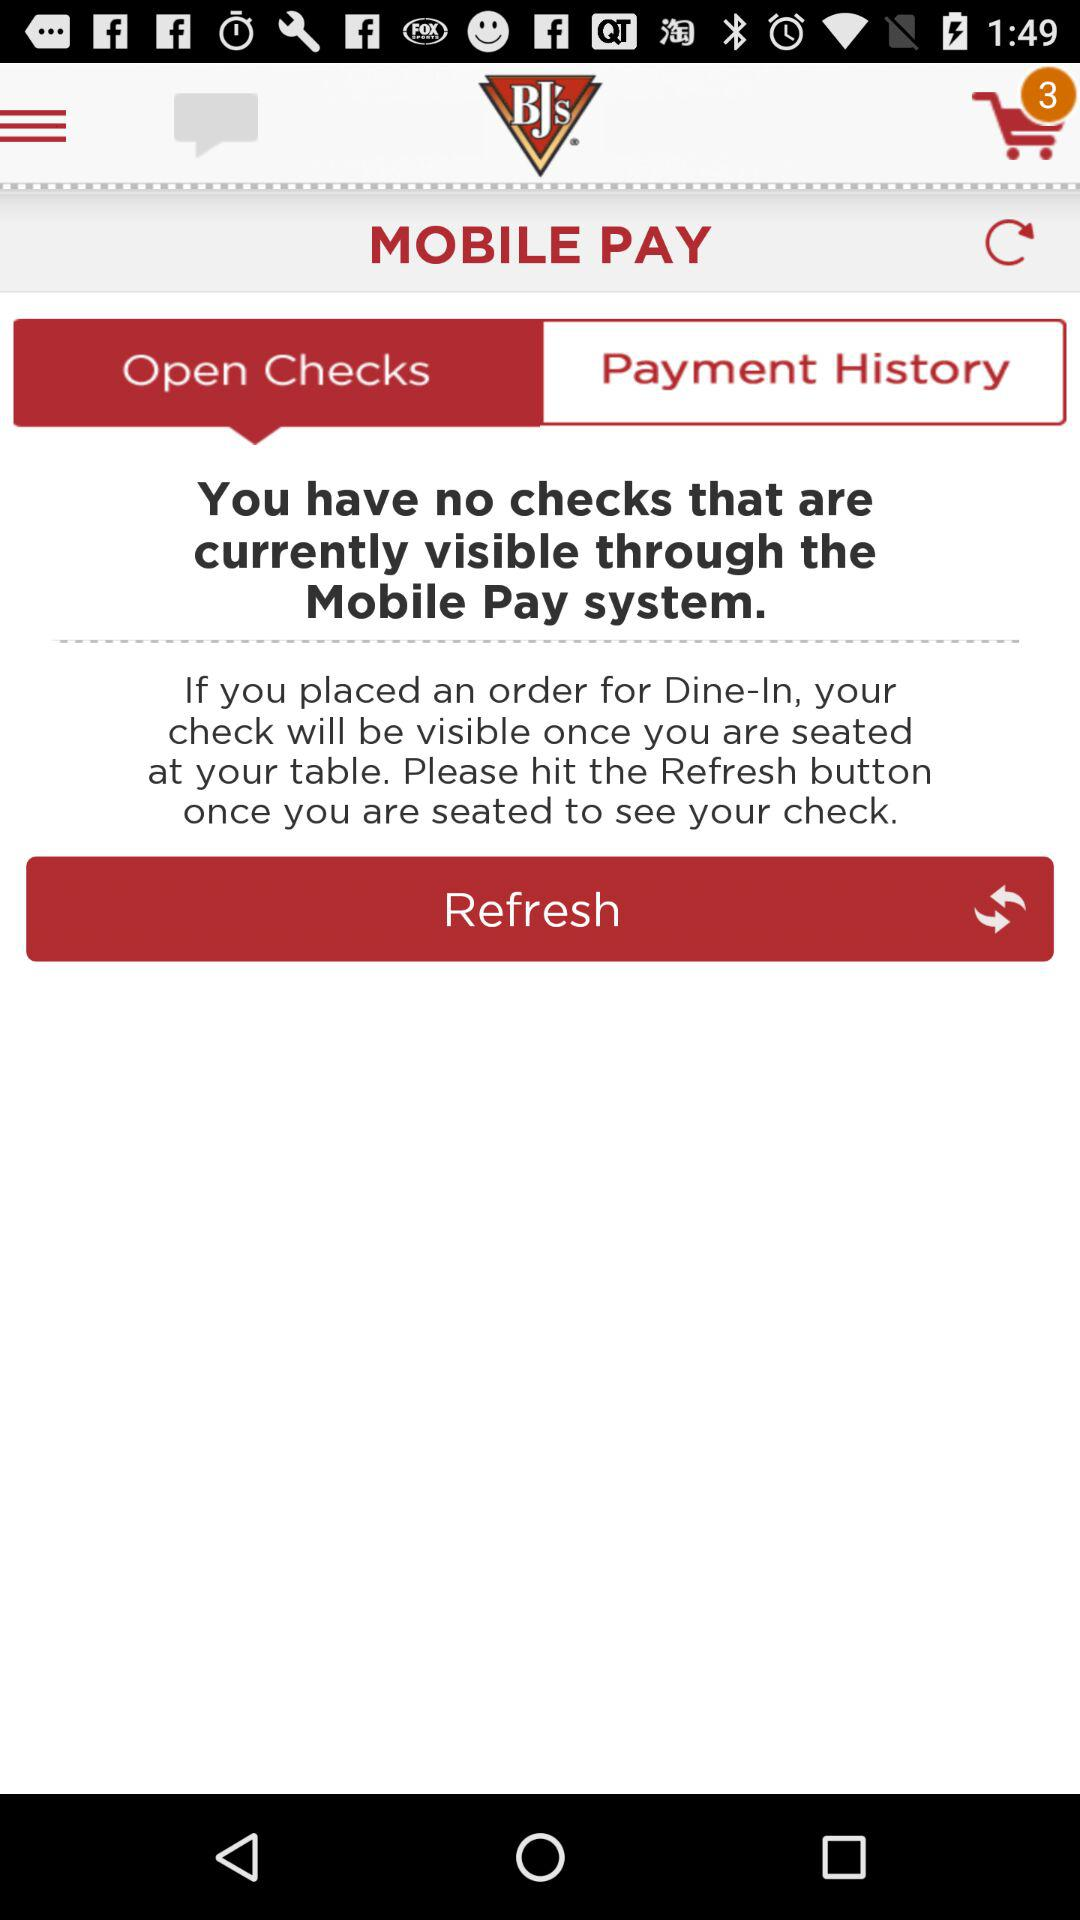How many checks are available to view?
Answer the question using a single word or phrase. 0 